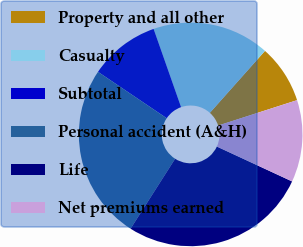<chart> <loc_0><loc_0><loc_500><loc_500><pie_chart><fcel>Property and all other<fcel>Casualty<fcel>Subtotal<fcel>Personal accident (A&H)<fcel>Life<fcel>Net premiums earned<nl><fcel>8.47%<fcel>16.95%<fcel>10.17%<fcel>25.42%<fcel>27.12%<fcel>11.86%<nl></chart> 